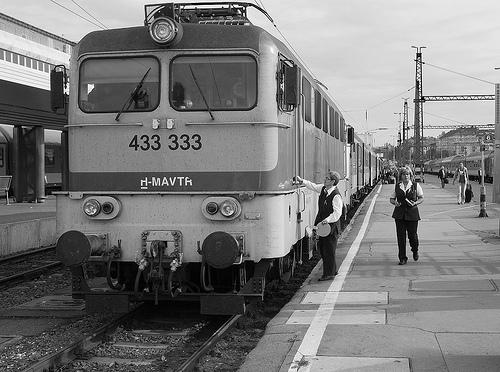Question: when was the picture taken?
Choices:
A. Yesterday.
B. Last week.
C. After the ceremony.
D. In the daytime.
Answer with the letter. Answer: D Question: what are the people doing?
Choices:
A. Painting.
B. Walking.
C. Conversing.
D. Studying.
Answer with the letter. Answer: B Question: what are the numbers on the train?
Choices:
A. 521 879.
B. 433 333.
C. 564 344.
D. 634 578.
Answer with the letter. Answer: B Question: who is in the picture?
Choices:
A. Passengers and train employees.
B. A baggage handler.
C. An engineer.
D. Nothing but the baggage cart.
Answer with the letter. Answer: A 